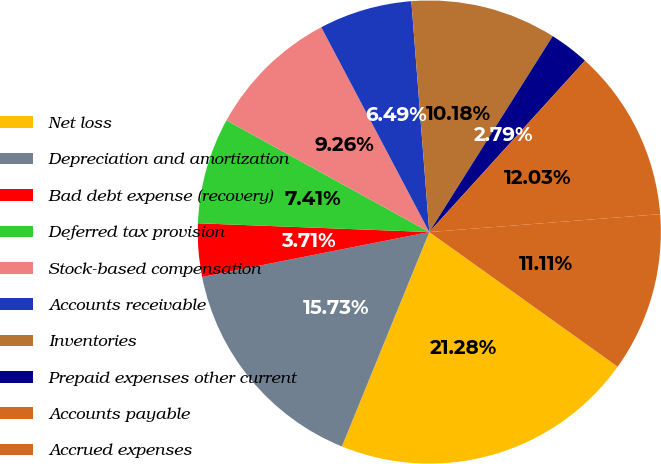Convert chart to OTSL. <chart><loc_0><loc_0><loc_500><loc_500><pie_chart><fcel>Net loss<fcel>Depreciation and amortization<fcel>Bad debt expense (recovery)<fcel>Deferred tax provision<fcel>Stock-based compensation<fcel>Accounts receivable<fcel>Inventories<fcel>Prepaid expenses other current<fcel>Accounts payable<fcel>Accrued expenses<nl><fcel>21.28%<fcel>15.73%<fcel>3.71%<fcel>7.41%<fcel>9.26%<fcel>6.49%<fcel>10.18%<fcel>2.79%<fcel>12.03%<fcel>11.11%<nl></chart> 